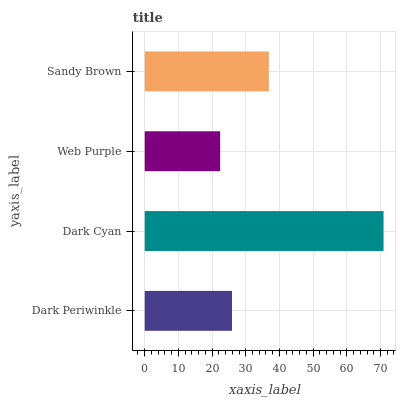Is Web Purple the minimum?
Answer yes or no. Yes. Is Dark Cyan the maximum?
Answer yes or no. Yes. Is Dark Cyan the minimum?
Answer yes or no. No. Is Web Purple the maximum?
Answer yes or no. No. Is Dark Cyan greater than Web Purple?
Answer yes or no. Yes. Is Web Purple less than Dark Cyan?
Answer yes or no. Yes. Is Web Purple greater than Dark Cyan?
Answer yes or no. No. Is Dark Cyan less than Web Purple?
Answer yes or no. No. Is Sandy Brown the high median?
Answer yes or no. Yes. Is Dark Periwinkle the low median?
Answer yes or no. Yes. Is Dark Periwinkle the high median?
Answer yes or no. No. Is Dark Cyan the low median?
Answer yes or no. No. 